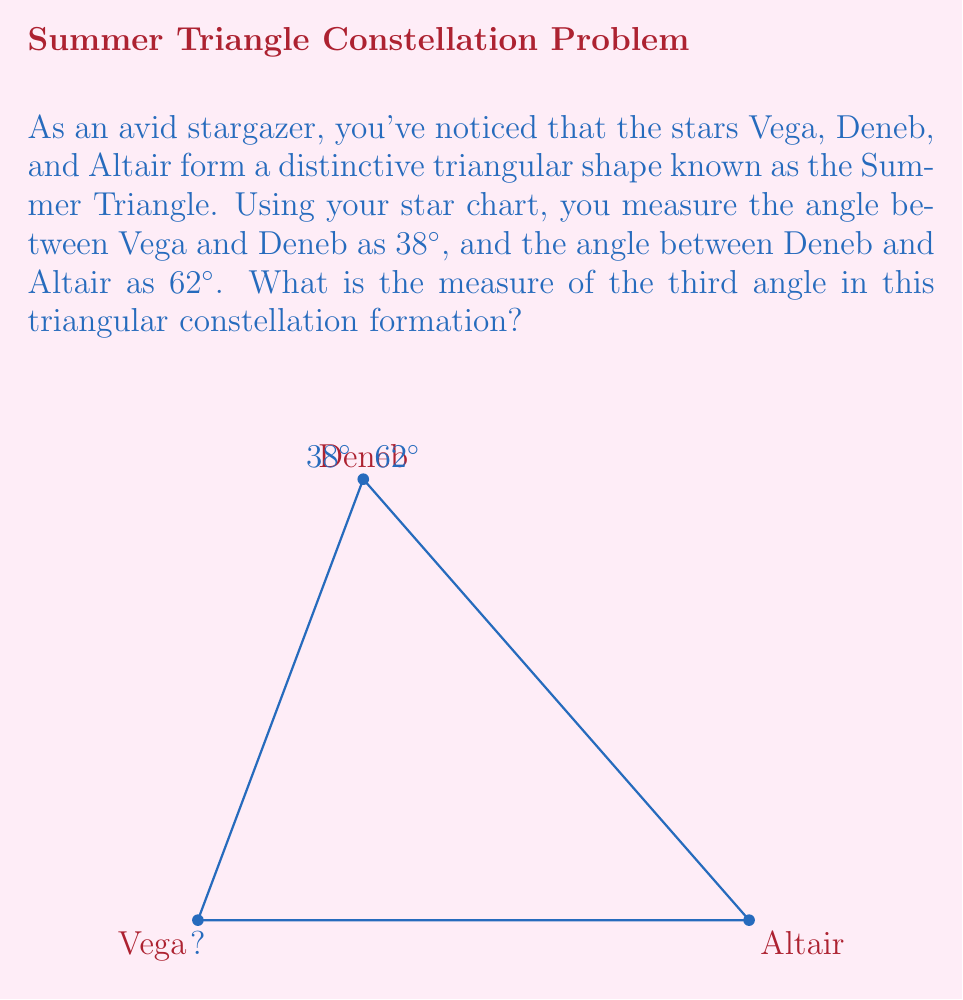Can you answer this question? To solve this problem, we'll use the fact that the sum of the angles in any triangle is always 180°. Let's approach this step-by-step:

1) Let's denote the unknown angle (between Vega and Altair) as $x$.

2) We know that:
   - The angle between Vega and Deneb is 38°
   - The angle between Deneb and Altair is 62°
   - The sum of all angles in a triangle is 180°

3) We can set up an equation:

   $$ 38° + 62° + x = 180° $$

4) Simplify the left side of the equation:

   $$ 100° + x = 180° $$

5) Subtract 100° from both sides:

   $$ x = 180° - 100° $$

6) Solve for $x$:

   $$ x = 80° $$

Therefore, the measure of the third angle in the Summer Triangle, between Vega and Altair, is 80°.
Answer: 80° 